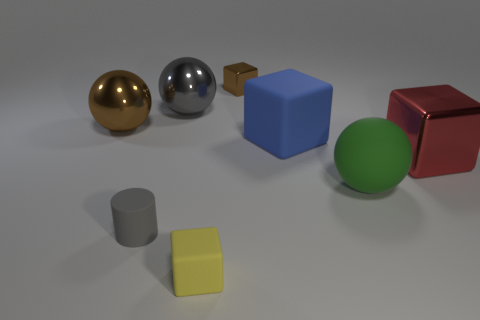The metal object that is behind the big red block and to the right of the yellow rubber block has what shape?
Provide a succinct answer. Cube. What number of other big matte objects have the same shape as the large gray thing?
Provide a short and direct response. 1. What is the size of the gray cylinder that is the same material as the blue object?
Provide a succinct answer. Small. How many red objects are the same size as the green rubber object?
Ensure brevity in your answer.  1. There is a metal ball that is the same color as the rubber cylinder; what is its size?
Offer a very short reply. Large. There is a large matte thing that is behind the big metallic object that is on the right side of the big blue rubber block; what is its color?
Give a very brief answer. Blue. Is there a small rubber object that has the same color as the tiny shiny object?
Keep it short and to the point. No. The rubber cube that is the same size as the red object is what color?
Your answer should be compact. Blue. Is the material of the large ball in front of the blue cube the same as the brown cube?
Provide a succinct answer. No. There is a block behind the large object left of the gray metal thing; is there a tiny gray rubber object that is to the left of it?
Offer a terse response. Yes. 